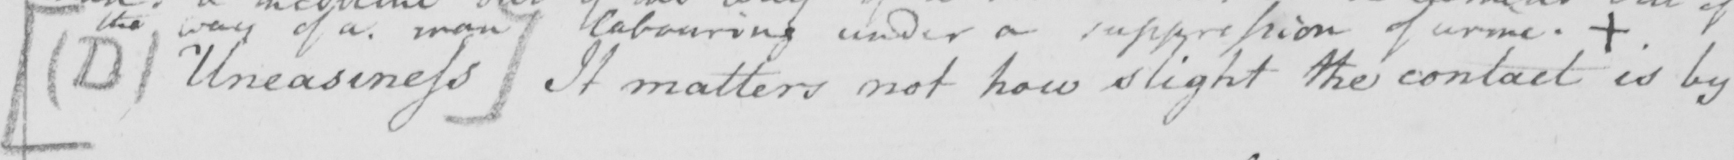Can you read and transcribe this handwriting? [  ( D )  Uneasiness ]  It matters not how slight the contact is by 